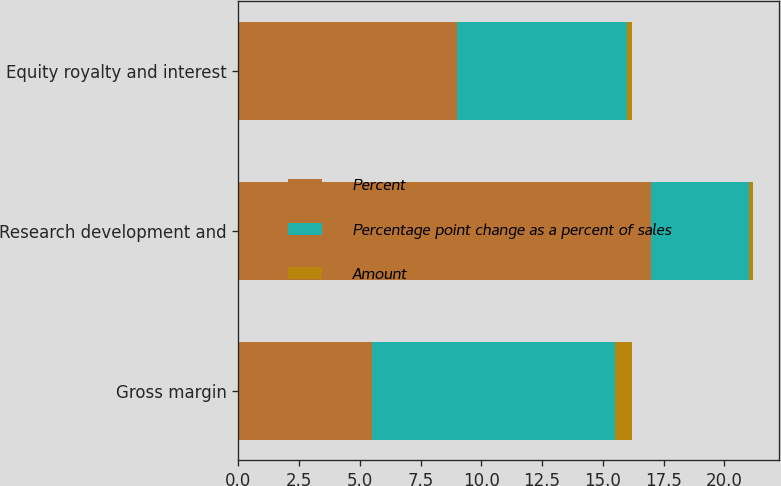Convert chart to OTSL. <chart><loc_0><loc_0><loc_500><loc_500><stacked_bar_chart><ecel><fcel>Gross margin<fcel>Research development and<fcel>Equity royalty and interest<nl><fcel>Percent<fcel>5.5<fcel>17<fcel>9<nl><fcel>Percentage point change as a percent of sales<fcel>10<fcel>4<fcel>7<nl><fcel>Amount<fcel>0.7<fcel>0.2<fcel>0.2<nl></chart> 